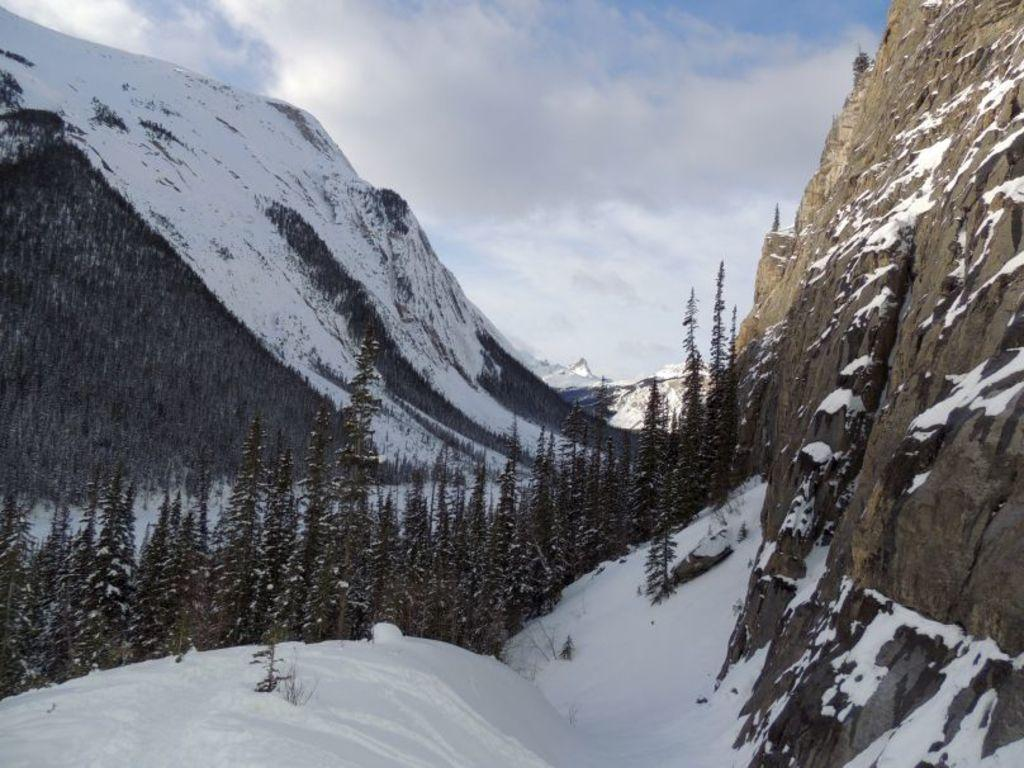What type of weather condition is depicted in the image? There is snow in the image, indicating a cold or wintry weather condition. What type of natural features can be seen in the image? There are trees, mountains, and clouds visible in the image. What part of the natural environment is visible in the image? The sky is visible in the image. What type of book can be seen floating in the water in the image? There is no book present in the image, and there is no water visible either. 